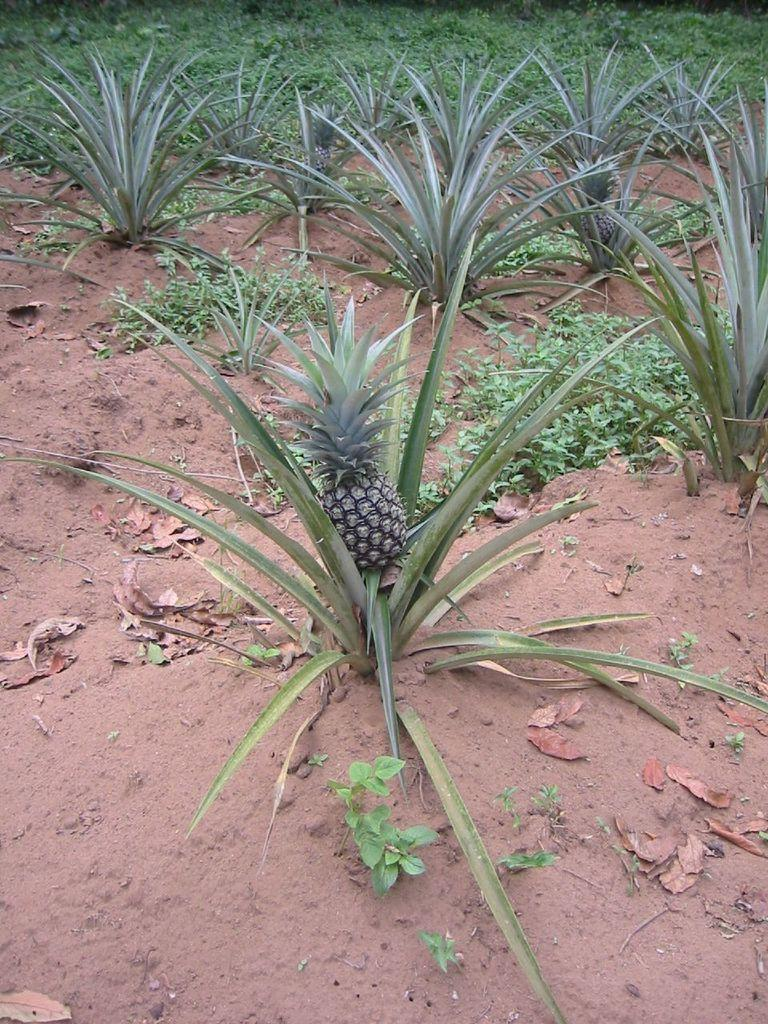What type of living organisms can be seen in the image? Plants can be seen in the image. What can be found on the ground near the plants? There are dried leaves on the ground in the image. What type of fruit is near the plants in the image? There are pineapples near the plants in the image. What type of powder can be seen covering the plants in the image? There is no powder present in the image; the plants are not covered in any substance. 